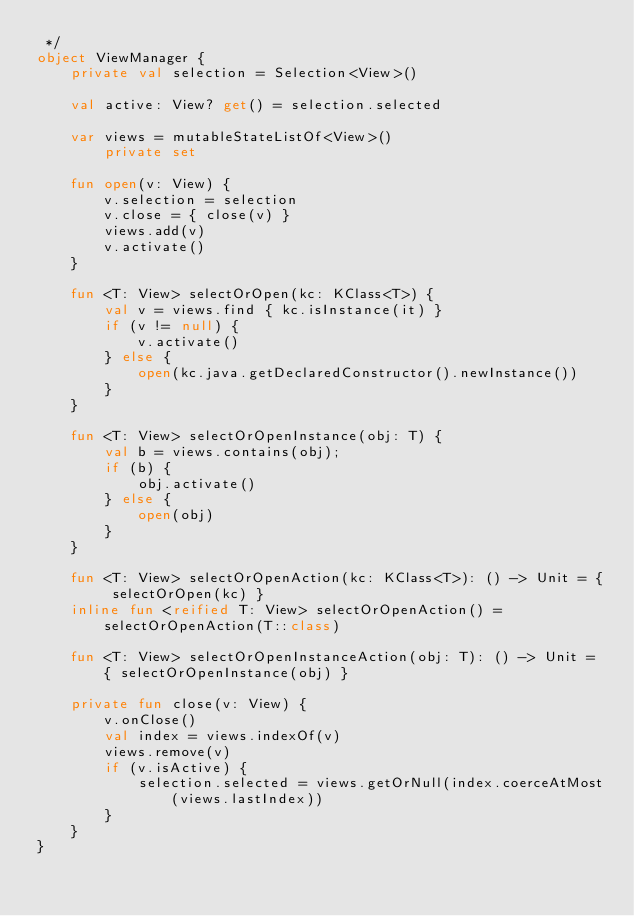Convert code to text. <code><loc_0><loc_0><loc_500><loc_500><_Kotlin_> */
object ViewManager {
    private val selection = Selection<View>()

    val active: View? get() = selection.selected

    var views = mutableStateListOf<View>()
        private set

    fun open(v: View) {
        v.selection = selection
        v.close = { close(v) }
        views.add(v)
        v.activate()
    }

    fun <T: View> selectOrOpen(kc: KClass<T>) {
        val v = views.find { kc.isInstance(it) }
        if (v != null) {
            v.activate()
        } else {
            open(kc.java.getDeclaredConstructor().newInstance())
        }
    }

    fun <T: View> selectOrOpenInstance(obj: T) {
        val b = views.contains(obj);
        if (b) {
            obj.activate()
        } else {
            open(obj)
        }
    }

    fun <T: View> selectOrOpenAction(kc: KClass<T>): () -> Unit = { selectOrOpen(kc) }
    inline fun <reified T: View> selectOrOpenAction() = selectOrOpenAction(T::class)

    fun <T: View> selectOrOpenInstanceAction(obj: T): () -> Unit = { selectOrOpenInstance(obj) }

    private fun close(v: View) {
        v.onClose()
        val index = views.indexOf(v)
        views.remove(v)
        if (v.isActive) {
            selection.selected = views.getOrNull(index.coerceAtMost(views.lastIndex))
        }
    }
}</code> 